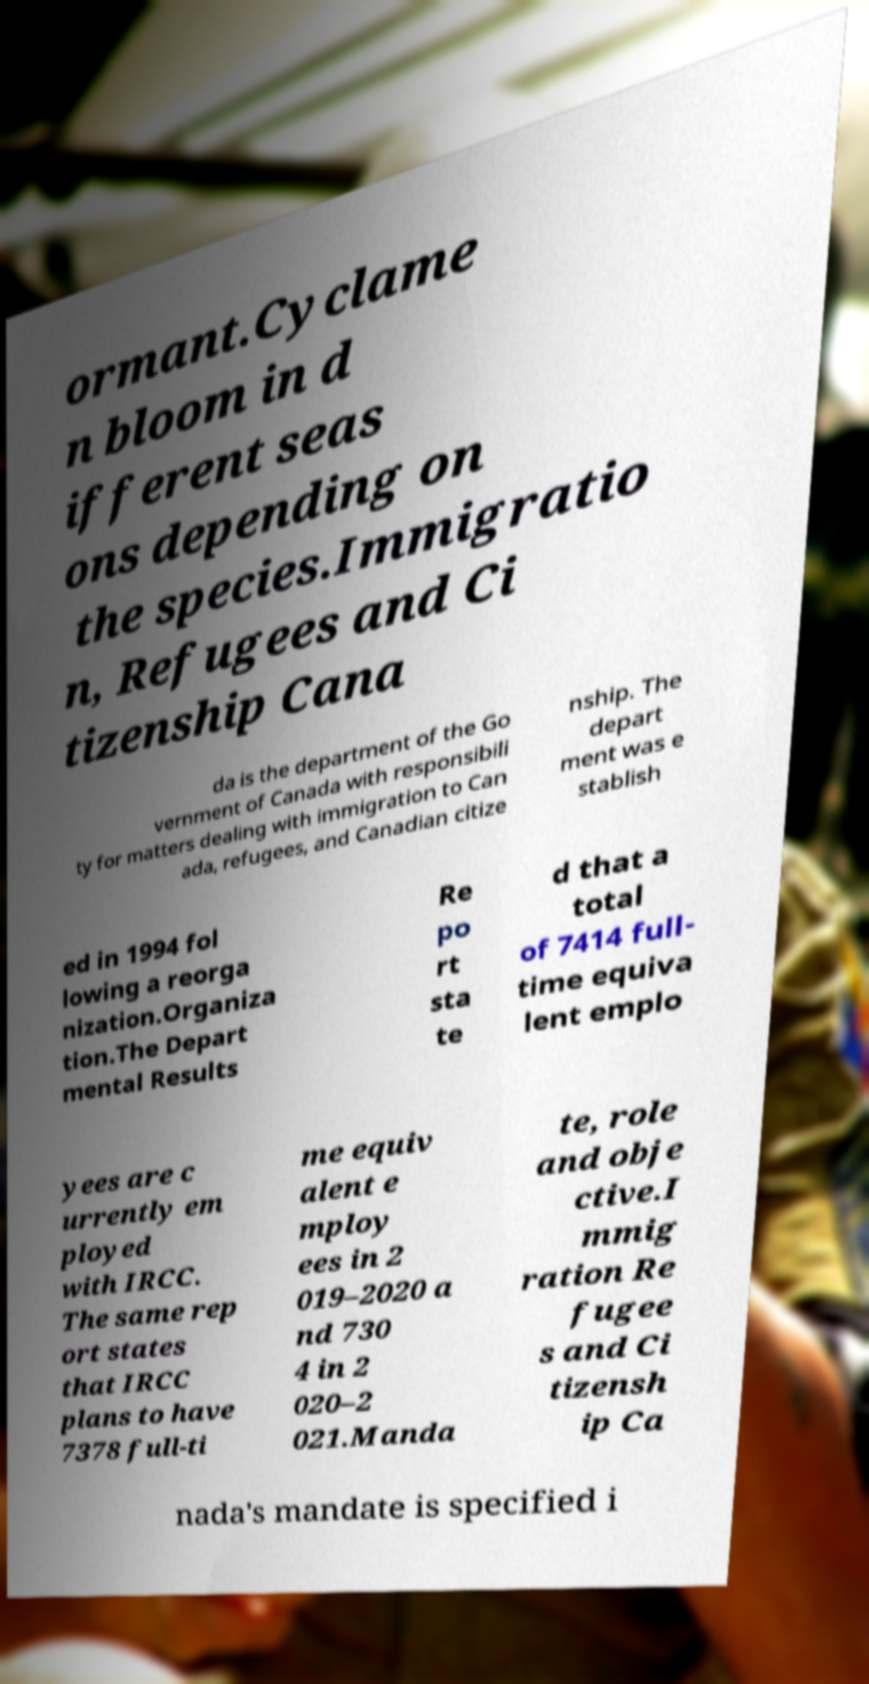Could you assist in decoding the text presented in this image and type it out clearly? ormant.Cyclame n bloom in d ifferent seas ons depending on the species.Immigratio n, Refugees and Ci tizenship Cana da is the department of the Go vernment of Canada with responsibili ty for matters dealing with immigration to Can ada, refugees, and Canadian citize nship. The depart ment was e stablish ed in 1994 fol lowing a reorga nization.Organiza tion.The Depart mental Results Re po rt sta te d that a total of 7414 full- time equiva lent emplo yees are c urrently em ployed with IRCC. The same rep ort states that IRCC plans to have 7378 full-ti me equiv alent e mploy ees in 2 019–2020 a nd 730 4 in 2 020–2 021.Manda te, role and obje ctive.I mmig ration Re fugee s and Ci tizensh ip Ca nada's mandate is specified i 